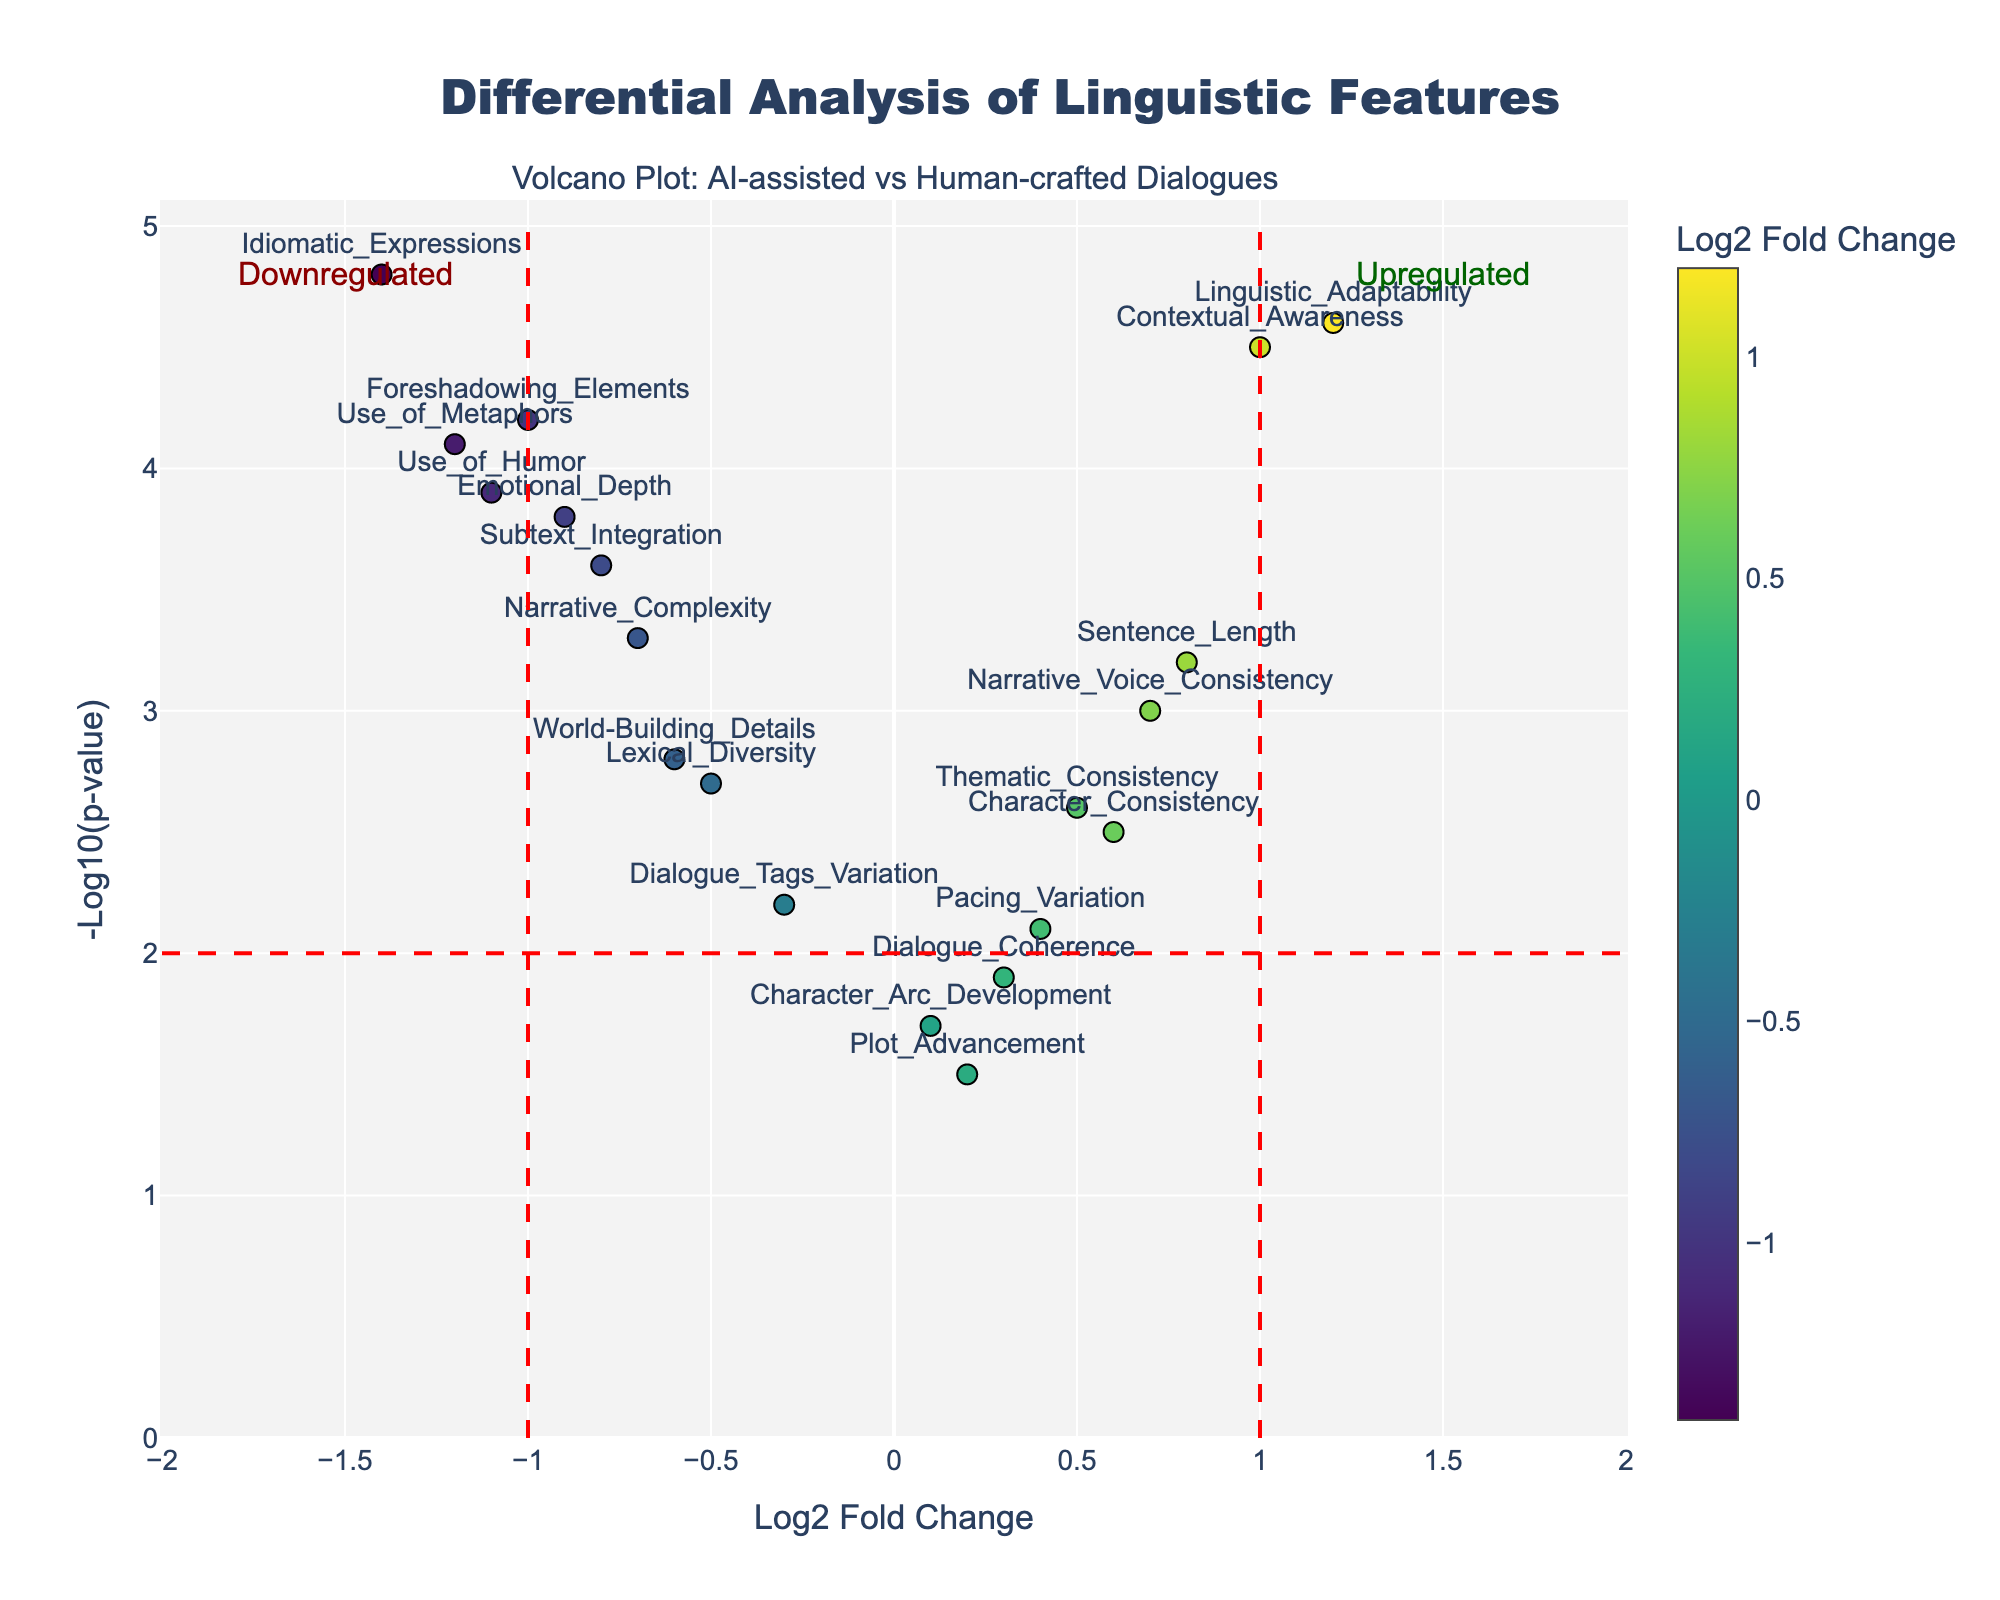Which feature has the highest negative log10 p-value? The feature with the highest negative log10 p-value is the one that is positioned highest on the y-axis.
Answer: Contextual_Awareness How many features have a log2 fold change greater than 1? To determine this, count the points on the plot that are located to the right of the vertical line at x = 1.
Answer: 2 Which feature is most upregulated? The feature with the highest log2 fold change value is the most upregulated. This is the point farthest to the right on the x-axis.
Answer: Linguistic_Adaptability Which features are downregulated with a negative log10 p-value greater than 4? Look for the points on the left of the vertical line at x = -1 that are above the horizontal line at y = 4.
Answer: Use_of_Metaphors, Idiomatic_Expressions, Foreshadowing_Elements What is the log2 fold change of the 'Use of Metaphors' feature? Find the 'Use of Metaphors' feature on the plot and read its log2 fold change value along the x-axis.
Answer: -1.2 What is the significance of the 'Dialogue Coherence' feature in terms of p-value? The significance is represented by the negative log10 p-value. Find 'Dialogue Coherence' and read its value along the y-axis.
Answer: 1.9 Are there more features upregulated or downregulated based on the given data? Compare the number of features with log2 fold changes greater than 0 (upregulated) and less than 0 (downregulated).
Answer: More downregulated Which feature shows the greatest decrease in linguistic features between AI-assisted and purely human-crafted dialogues? Look for the feature with the lowest log2 fold change value on the left side of the plot.
Answer: Idiomatic_Expressions How does 'Lexical Diversity' compare to 'Narrative Voice Consistency' in terms of log2 fold change? Compare the x-axis positions of 'Lexical Diversity' and 'Narrative Voice Consistency'.
Answer: Lexical_Diversity is lower What does a negative log2 fold change indicate in this plot? A negative log2 fold change indicates that the feature is more prevalent in purely human-crafted dialogues compared to AI-assisted dialogues.
Answer: More in human-crafted 